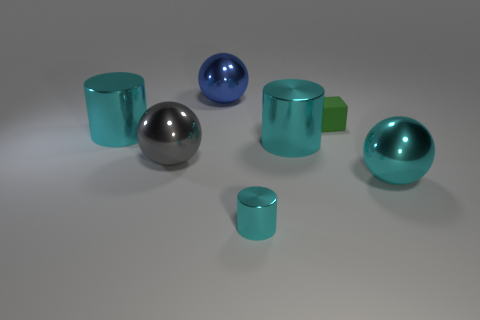Is there anything else that is made of the same material as the small cube?
Offer a terse response. No. What is the material of the sphere that is the same color as the tiny metallic cylinder?
Your response must be concise. Metal. There is a cyan thing that is the same size as the cube; what is it made of?
Keep it short and to the point. Metal. There is a cylinder that is both to the right of the large gray metal thing and behind the tiny cyan metallic object; what material is it?
Ensure brevity in your answer.  Metal. Is there a tiny cyan object behind the cyan metallic thing that is right of the matte thing?
Your answer should be compact. No. There is a metal thing that is left of the blue metal sphere and behind the big gray object; how big is it?
Provide a succinct answer. Large. How many blue things are either big shiny objects or small rubber blocks?
Your response must be concise. 1. What shape is the gray thing that is the same size as the blue thing?
Provide a short and direct response. Sphere. How many other things are there of the same color as the tiny matte thing?
Your answer should be compact. 0. There is a cyan metal thing in front of the thing that is right of the matte thing; what size is it?
Keep it short and to the point. Small. 